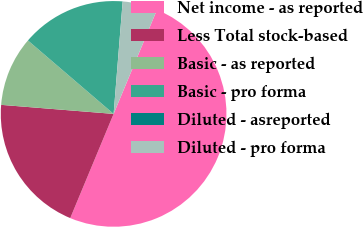Convert chart. <chart><loc_0><loc_0><loc_500><loc_500><pie_chart><fcel>Net income - as reported<fcel>Less Total stock-based<fcel>Basic - as reported<fcel>Basic - pro forma<fcel>Diluted - asreported<fcel>Diluted - pro forma<nl><fcel>50.0%<fcel>20.0%<fcel>10.0%<fcel>15.0%<fcel>0.0%<fcel>5.0%<nl></chart> 